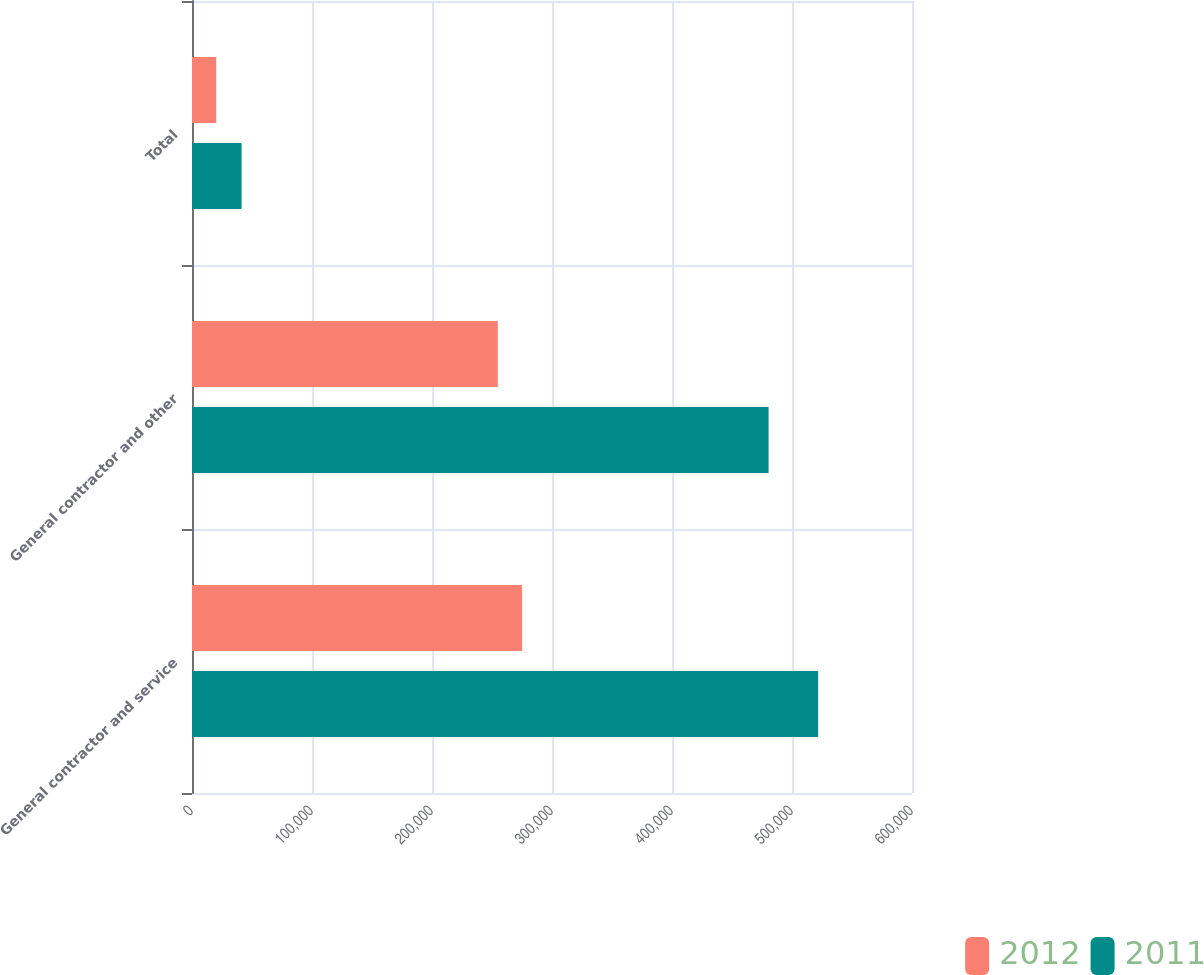Convert chart to OTSL. <chart><loc_0><loc_0><loc_500><loc_500><stacked_bar_chart><ecel><fcel>General contractor and service<fcel>General contractor and other<fcel>Total<nl><fcel>2012<fcel>275071<fcel>254870<fcel>20201<nl><fcel>2011<fcel>521796<fcel>480480<fcel>41316<nl></chart> 